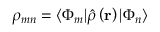Convert formula to latex. <formula><loc_0><loc_0><loc_500><loc_500>\rho _ { m n } = \langle \Phi _ { m } | \hat { \rho } \left ( r \right ) | \Phi _ { n } \rangle</formula> 